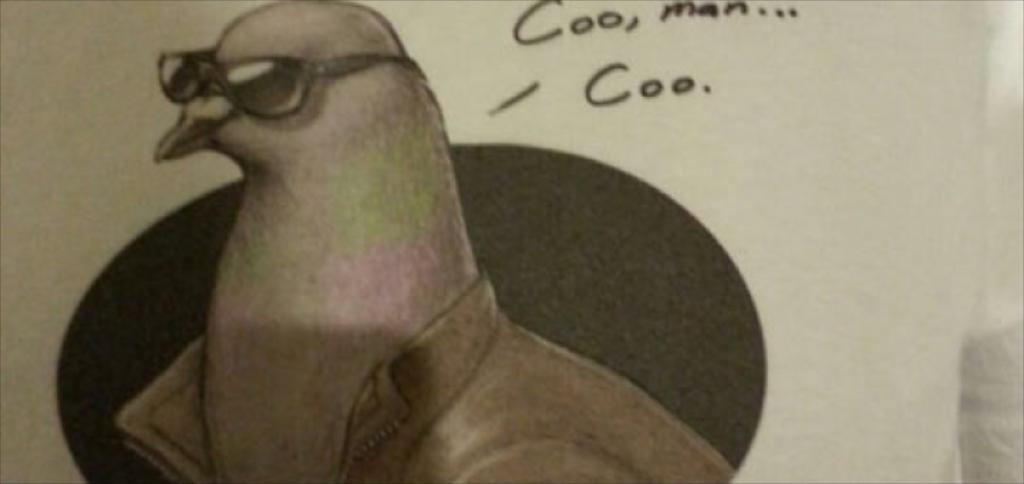What type of animal can be seen in the image? There is a bird in the image. What accessory is present in the image? There are goggles in the image. Is there any text visible in the image? Yes, there is text in the image. What type of cork can be seen on the bird's head in the image? There is no cork present on the bird's head in the image. Is there a crown visible on the bird in the image? There is no crown visible on the bird in the image. 